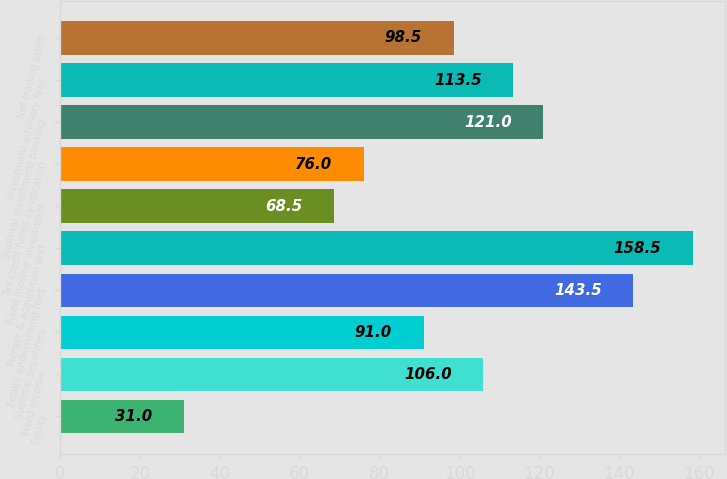<chart> <loc_0><loc_0><loc_500><loc_500><bar_chart><fcel>Equity<fcel>Fixed income<fcel>Subtotal securities<fcel>Equity underwriting fees<fcel>Merger & acquisition and<fcel>Fixed income investment<fcel>Tax credit funds syndication<fcel>Subtotal investment banking<fcel>Investment advisory fees<fcel>Net trading profit<nl><fcel>31<fcel>106<fcel>91<fcel>143.5<fcel>158.5<fcel>68.5<fcel>76<fcel>121<fcel>113.5<fcel>98.5<nl></chart> 